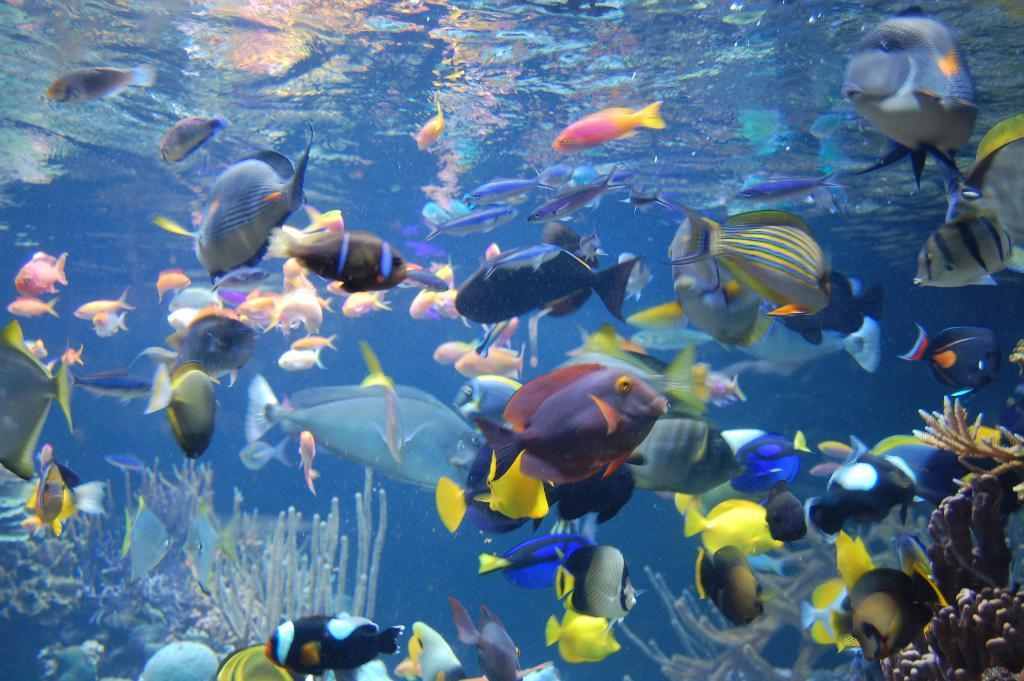Where was the image taken? The image was taken under the sea. What is the primary element visible in the image? There is water in the image. What type of underwater structures can be seen in the image? There are coral reefs in the image. How many types of marine life can be observed in the image? There are many fishes in the image. What type of sink can be seen in the image? There is no sink present in the image, as it was taken under the sea. 